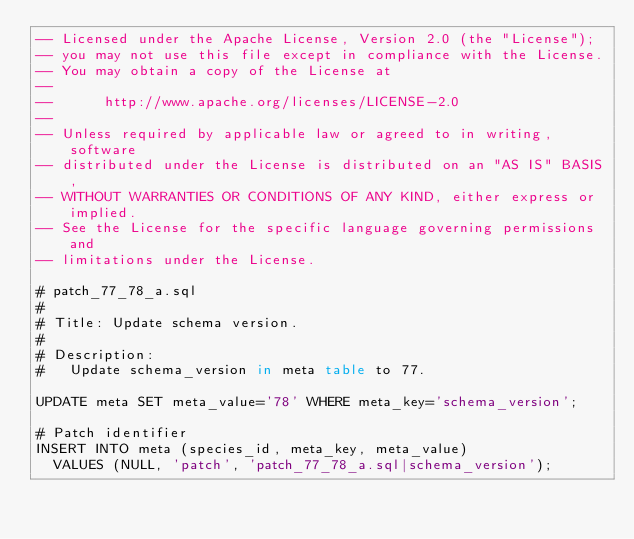Convert code to text. <code><loc_0><loc_0><loc_500><loc_500><_SQL_>-- Licensed under the Apache License, Version 2.0 (the "License");
-- you may not use this file except in compliance with the License.
-- You may obtain a copy of the License at
-- 
--      http://www.apache.org/licenses/LICENSE-2.0
-- 
-- Unless required by applicable law or agreed to in writing, software
-- distributed under the License is distributed on an "AS IS" BASIS,
-- WITHOUT WARRANTIES OR CONDITIONS OF ANY KIND, either express or implied.
-- See the License for the specific language governing permissions and
-- limitations under the License.

# patch_77_78_a.sql
#
# Title: Update schema version.
#
# Description:
#   Update schema_version in meta table to 77.

UPDATE meta SET meta_value='78' WHERE meta_key='schema_version';

# Patch identifier
INSERT INTO meta (species_id, meta_key, meta_value)
  VALUES (NULL, 'patch', 'patch_77_78_a.sql|schema_version');
</code> 